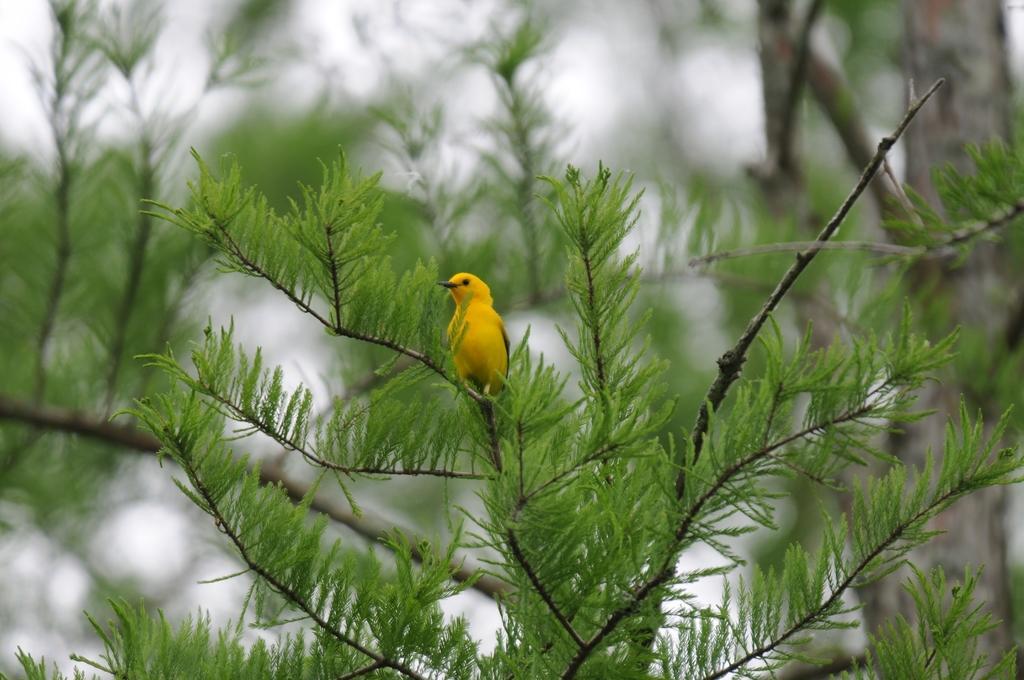Please provide a concise description of this image. In this image we can see a bird on a tree with blur background. 